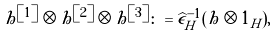<formula> <loc_0><loc_0><loc_500><loc_500>h ^ { \left [ 1 \right ] } \otimes h ^ { \left [ 2 \right ] } \otimes h ^ { \left [ 3 \right ] } \colon = \widehat { \epsilon } _ { H } ^ { - 1 } ( h \otimes 1 _ { H } ) ,</formula> 